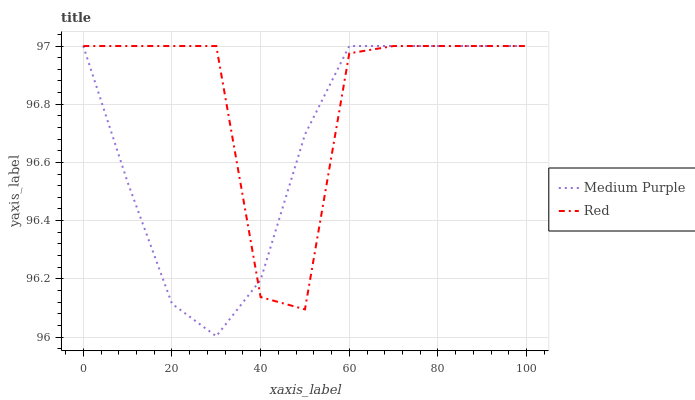Does Medium Purple have the minimum area under the curve?
Answer yes or no. Yes. Does Red have the maximum area under the curve?
Answer yes or no. Yes. Does Red have the minimum area under the curve?
Answer yes or no. No. Is Medium Purple the smoothest?
Answer yes or no. Yes. Is Red the roughest?
Answer yes or no. Yes. Is Red the smoothest?
Answer yes or no. No. Does Medium Purple have the lowest value?
Answer yes or no. Yes. Does Red have the lowest value?
Answer yes or no. No. Does Red have the highest value?
Answer yes or no. Yes. Does Red intersect Medium Purple?
Answer yes or no. Yes. Is Red less than Medium Purple?
Answer yes or no. No. Is Red greater than Medium Purple?
Answer yes or no. No. 